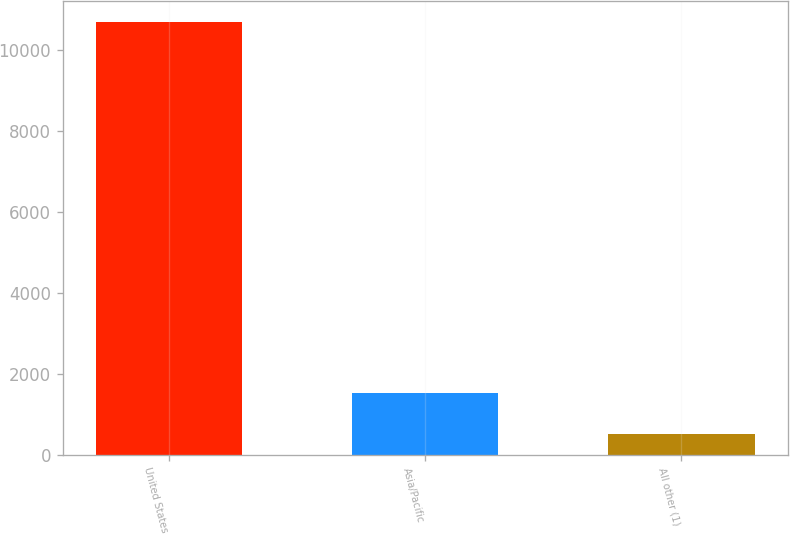Convert chart. <chart><loc_0><loc_0><loc_500><loc_500><bar_chart><fcel>United States<fcel>Asia/Pacific<fcel>All other (1)<nl><fcel>10676<fcel>1527.5<fcel>511<nl></chart> 